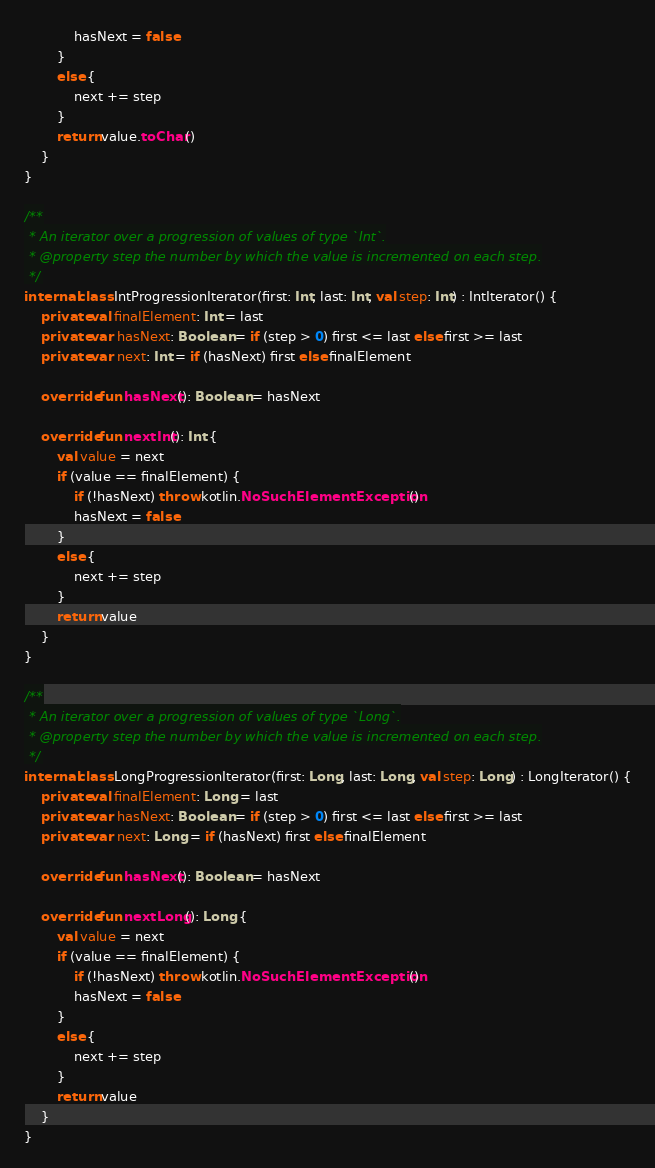Convert code to text. <code><loc_0><loc_0><loc_500><loc_500><_Kotlin_>            hasNext = false
        }
        else {
            next += step
        }
        return value.toChar()
    }
}

/**
 * An iterator over a progression of values of type `Int`.
 * @property step the number by which the value is incremented on each step.
 */
internal class IntProgressionIterator(first: Int, last: Int, val step: Int) : IntIterator() {
    private val finalElement: Int = last
    private var hasNext: Boolean = if (step > 0) first <= last else first >= last
    private var next: Int = if (hasNext) first else finalElement

    override fun hasNext(): Boolean = hasNext

    override fun nextInt(): Int {
        val value = next
        if (value == finalElement) {
            if (!hasNext) throw kotlin.NoSuchElementException()
            hasNext = false
        }
        else {
            next += step
        }
        return value
    }
}

/**
 * An iterator over a progression of values of type `Long`.
 * @property step the number by which the value is incremented on each step.
 */
internal class LongProgressionIterator(first: Long, last: Long, val step: Long) : LongIterator() {
    private val finalElement: Long = last
    private var hasNext: Boolean = if (step > 0) first <= last else first >= last
    private var next: Long = if (hasNext) first else finalElement

    override fun hasNext(): Boolean = hasNext

    override fun nextLong(): Long {
        val value = next
        if (value == finalElement) {
            if (!hasNext) throw kotlin.NoSuchElementException()
            hasNext = false
        }
        else {
            next += step
        }
        return value
    }
}

</code> 